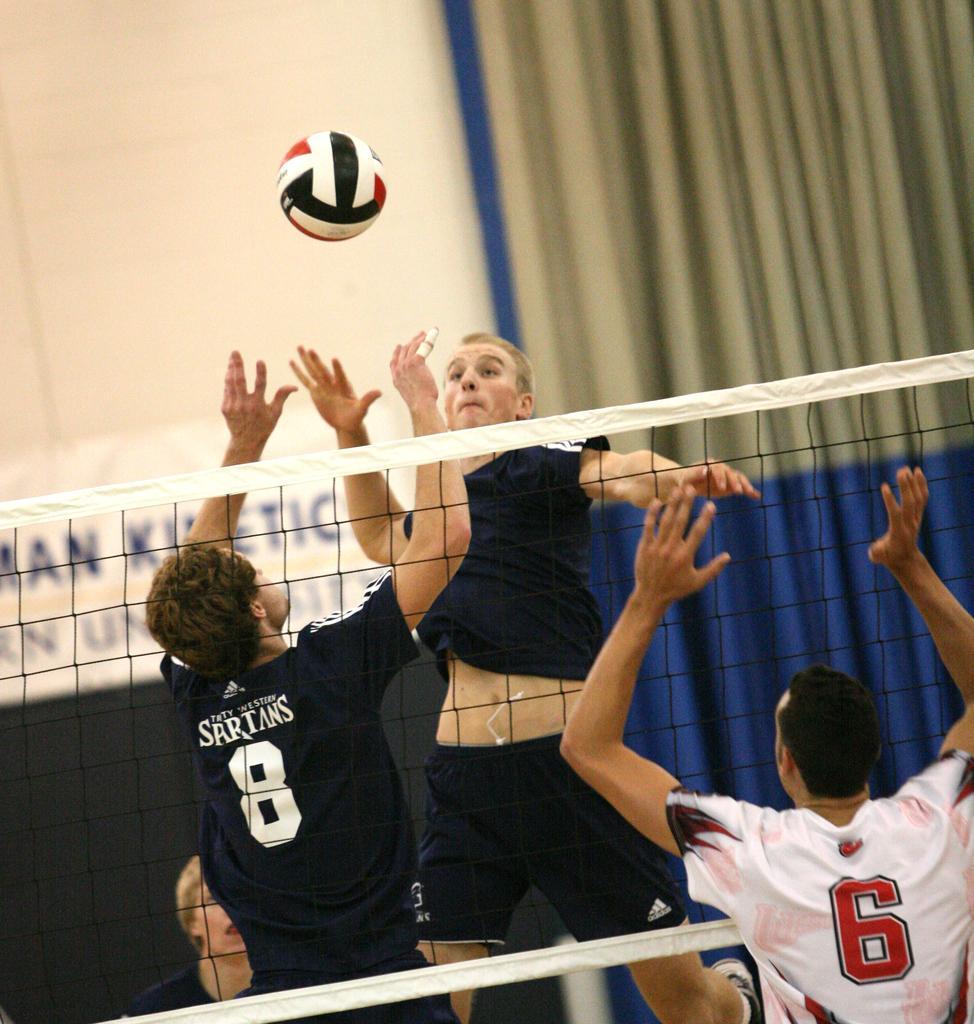Please provide a concise description of this image. In this picture we can see few players playing a throw ball. This is a mesh net. On the background of the picture we can see a wall and also a curtain. This is a ball. 